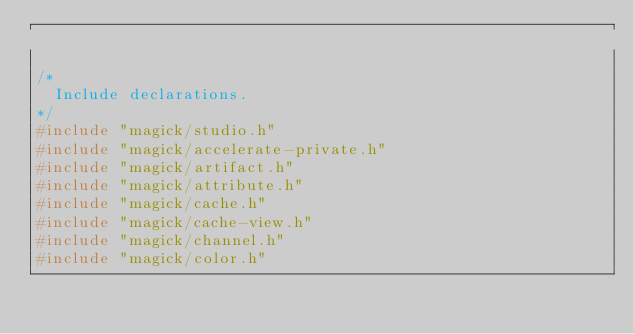Convert code to text. <code><loc_0><loc_0><loc_500><loc_500><_C_>
/*
  Include declarations.
*/
#include "magick/studio.h"
#include "magick/accelerate-private.h"
#include "magick/artifact.h"
#include "magick/attribute.h"
#include "magick/cache.h"
#include "magick/cache-view.h"
#include "magick/channel.h"
#include "magick/color.h"</code> 